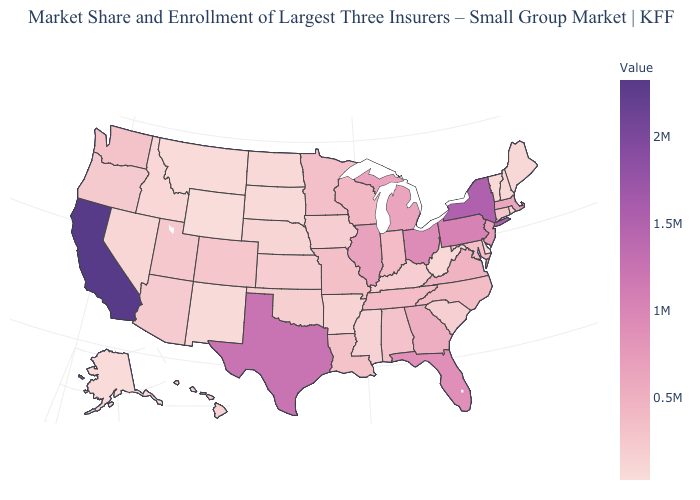Which states have the highest value in the USA?
Concise answer only. California. Among the states that border Virginia , which have the highest value?
Short answer required. Tennessee. Does Delaware have the lowest value in the South?
Quick response, please. Yes. Does South Dakota have the highest value in the MidWest?
Quick response, please. No. Does Minnesota have the lowest value in the USA?
Concise answer only. No. 